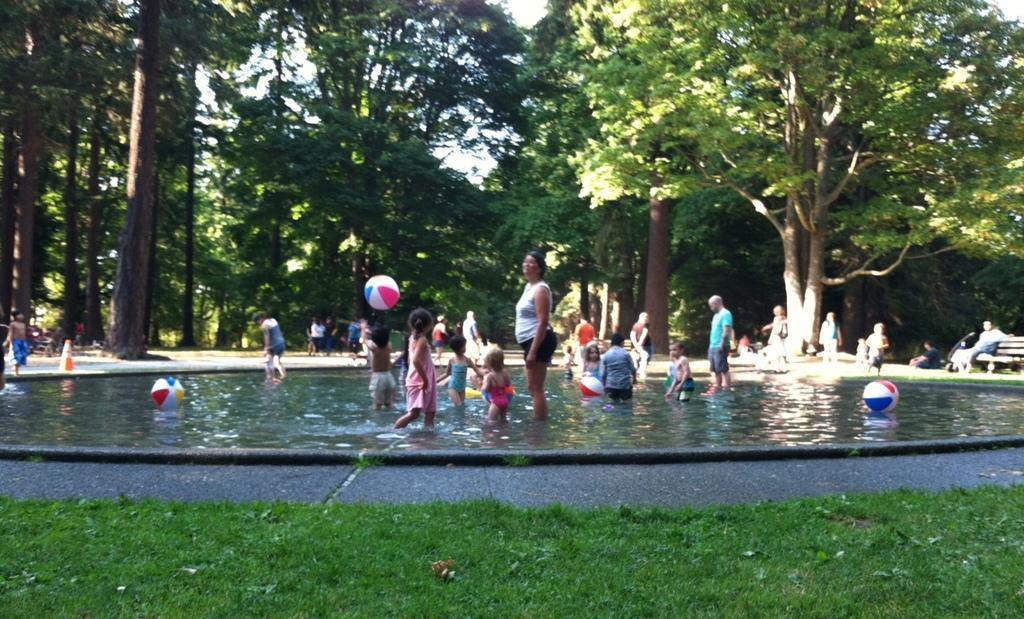Can you describe this image briefly? In this picture there is a swimming pool in the center of the image and there are children in it, there is grassland at the bottom side of the image and there are trees in the background area of the image. 